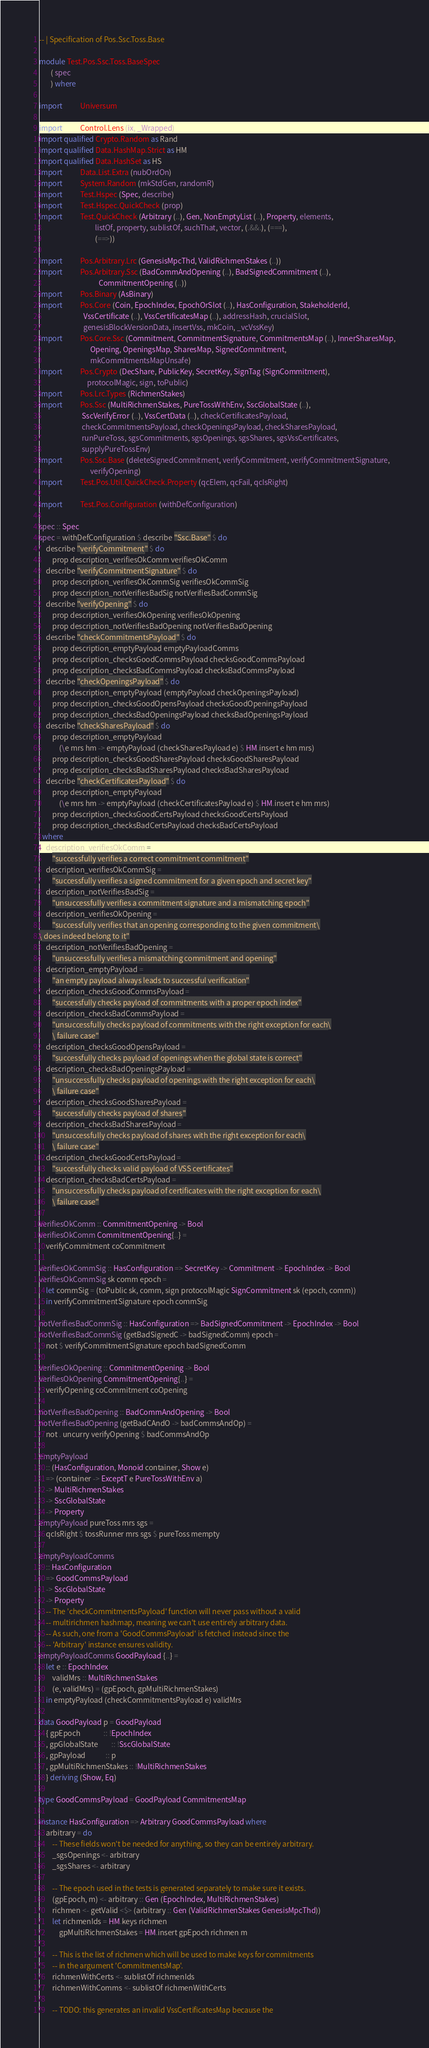<code> <loc_0><loc_0><loc_500><loc_500><_Haskell_>-- | Specification of Pos.Ssc.Toss.Base

module Test.Pos.Ssc.Toss.BaseSpec
       ( spec
       ) where

import           Universum

import           Control.Lens (ix, _Wrapped)
import qualified Crypto.Random as Rand
import qualified Data.HashMap.Strict as HM
import qualified Data.HashSet as HS
import           Data.List.Extra (nubOrdOn)
import           System.Random (mkStdGen, randomR)
import           Test.Hspec (Spec, describe)
import           Test.Hspec.QuickCheck (prop)
import           Test.QuickCheck (Arbitrary (..), Gen, NonEmptyList (..), Property, elements,
                                  listOf, property, sublistOf, suchThat, vector, (.&&.), (===),
                                  (==>))

import           Pos.Arbitrary.Lrc (GenesisMpcThd, ValidRichmenStakes (..))
import           Pos.Arbitrary.Ssc (BadCommAndOpening (..), BadSignedCommitment (..),
                                    CommitmentOpening (..))
import           Pos.Binary (AsBinary)
import           Pos.Core (Coin, EpochIndex, EpochOrSlot (..), HasConfiguration, StakeholderId,
                           VssCertificate (..), VssCertificatesMap (..), addressHash, crucialSlot,
                           genesisBlockVersionData, insertVss, mkCoin, _vcVssKey)
import           Pos.Core.Ssc (Commitment, CommitmentSignature, CommitmentsMap (..), InnerSharesMap,
                               Opening, OpeningsMap, SharesMap, SignedCommitment,
                               mkCommitmentsMapUnsafe)
import           Pos.Crypto (DecShare, PublicKey, SecretKey, SignTag (SignCommitment),
                             protocolMagic, sign, toPublic)
import           Pos.Lrc.Types (RichmenStakes)
import           Pos.Ssc (MultiRichmenStakes, PureTossWithEnv, SscGlobalState (..),
                          SscVerifyError (..), VssCertData (..), checkCertificatesPayload,
                          checkCommitmentsPayload, checkOpeningsPayload, checkSharesPayload,
                          runPureToss, sgsCommitments, sgsOpenings, sgsShares, sgsVssCertificates,
                          supplyPureTossEnv)
import           Pos.Ssc.Base (deleteSignedCommitment, verifyCommitment, verifyCommitmentSignature,
                               verifyOpening)
import           Test.Pos.Util.QuickCheck.Property (qcElem, qcFail, qcIsRight)

import           Test.Pos.Configuration (withDefConfiguration)

spec :: Spec
spec = withDefConfiguration $ describe "Ssc.Base" $ do
    describe "verifyCommitment" $ do
        prop description_verifiesOkComm verifiesOkComm
    describe "verifyCommitmentSignature" $ do
        prop description_verifiesOkCommSig verifiesOkCommSig
        prop description_notVerifiesBadSig notVerifiesBadCommSig
    describe "verifyOpening" $ do
        prop description_verifiesOkOpening verifiesOkOpening
        prop description_notVerifiesBadOpening notVerifiesBadOpening
    describe "checkCommitmentsPayload" $ do
        prop description_emptyPayload emptyPayloadComms
        prop description_checksGoodCommsPayload checksGoodCommsPayload
        prop description_checksBadCommsPayload checksBadCommsPayload
    describe "checkOpeningsPayload" $ do
        prop description_emptyPayload (emptyPayload checkOpeningsPayload)
        prop description_checksGoodOpensPayload checksGoodOpeningsPayload
        prop description_checksBadOpeningsPayload checksBadOpeningsPayload
    describe "checkSharesPayload" $ do
        prop description_emptyPayload
            (\e mrs hm -> emptyPayload (checkSharesPayload e) $ HM.insert e hm mrs)
        prop description_checksGoodSharesPayload checksGoodSharesPayload
        prop description_checksBadSharesPayload checksBadSharesPayload
    describe "checkCertificatesPayload" $ do
        prop description_emptyPayload
            (\e mrs hm -> emptyPayload (checkCertificatesPayload e) $ HM.insert e hm mrs)
        prop description_checksGoodCertsPayload checksGoodCertsPayload
        prop description_checksBadCertsPayload checksBadCertsPayload
  where
    description_verifiesOkComm =
        "successfully verifies a correct commitment commitment"
    description_verifiesOkCommSig =
        "successfully verifies a signed commitment for a given epoch and secret key"
    description_notVerifiesBadSig =
        "unsuccessfully verifies a commitment signature and a mismatching epoch"
    description_verifiesOkOpening =
        "successfully verifies that an opening corresponding to the given commitment\
\ does indeed belong to it"
    description_notVerifiesBadOpening =
        "unsuccessfully verifies a mismatching commitment and opening"
    description_emptyPayload =
        "an empty payload always leads to successful verification"
    description_checksGoodCommsPayload =
        "successfully checks payload of commitments with a proper epoch index"
    description_checksBadCommsPayload =
        "unsuccessfully checks payload of commitments with the right exception for each\
        \ failure case"
    description_checksGoodOpensPayload =
        "successfully checks payload of openings when the global state is correct"
    description_checksBadOpeningsPayload =
        "unsuccessfully checks payload of openings with the right exception for each\
        \ failure case"
    description_checksGoodSharesPayload =
        "successfully checks payload of shares"
    description_checksBadSharesPayload =
        "unsuccessfully checks payload of shares with the right exception for each\
        \ failure case"
    description_checksGoodCertsPayload =
        "successfully checks valid payload of VSS certificates"
    description_checksBadCertsPayload =
        "unsuccessfully checks payload of certificates with the right exception for each\
        \ failure case"

verifiesOkComm :: CommitmentOpening -> Bool
verifiesOkComm CommitmentOpening{..} =
    verifyCommitment coCommitment

verifiesOkCommSig :: HasConfiguration => SecretKey -> Commitment -> EpochIndex -> Bool
verifiesOkCommSig sk comm epoch =
    let commSig = (toPublic sk, comm, sign protocolMagic SignCommitment sk (epoch, comm))
    in verifyCommitmentSignature epoch commSig

notVerifiesBadCommSig :: HasConfiguration => BadSignedCommitment -> EpochIndex -> Bool
notVerifiesBadCommSig (getBadSignedC -> badSignedComm) epoch =
    not $ verifyCommitmentSignature epoch badSignedComm

verifiesOkOpening :: CommitmentOpening -> Bool
verifiesOkOpening CommitmentOpening{..} =
    verifyOpening coCommitment coOpening

notVerifiesBadOpening :: BadCommAndOpening -> Bool
notVerifiesBadOpening (getBadCAndO -> badCommsAndOp) =
    not . uncurry verifyOpening $ badCommsAndOp

emptyPayload
    :: (HasConfiguration, Monoid container, Show e)
    => (container -> ExceptT e PureTossWithEnv a)
    -> MultiRichmenStakes
    -> SscGlobalState
    -> Property
emptyPayload pureToss mrs sgs =
    qcIsRight $ tossRunner mrs sgs $ pureToss mempty

emptyPayloadComms
    :: HasConfiguration
    => GoodCommsPayload
    -> SscGlobalState
    -> Property
    -- The 'checkCommitmentsPayload' function will never pass without a valid
    -- multirichmen hashmap, meaning we can't use entirely arbitrary data.
    -- As such, one from a 'GoodCommsPayload' is fetched instead since the
    -- 'Arbitrary' instance ensures validity.
emptyPayloadComms GoodPayload {..} =
    let e :: EpochIndex
        validMrs :: MultiRichmenStakes
        (e, validMrs) = (gpEpoch, gpMultiRichmenStakes)
    in emptyPayload (checkCommitmentsPayload e) validMrs

data GoodPayload p = GoodPayload
    { gpEpoch              :: !EpochIndex
    , gpGlobalState        :: !SscGlobalState
    , gpPayload            :: p
    , gpMultiRichmenStakes :: !MultiRichmenStakes
    } deriving (Show, Eq)

type GoodCommsPayload = GoodPayload CommitmentsMap

instance HasConfiguration => Arbitrary GoodCommsPayload where
    arbitrary = do
        -- These fields won't be needed for anything, so they can be entirely arbitrary.
        _sgsOpenings <- arbitrary
        _sgsShares <- arbitrary

        -- The epoch used in the tests is generated separately to make sure it exists.
        (gpEpoch, m) <- arbitrary :: Gen (EpochIndex, MultiRichmenStakes)
        richmen <- getValid <$> (arbitrary :: Gen (ValidRichmenStakes GenesisMpcThd))
        let richmenIds = HM.keys richmen
            gpMultiRichmenStakes = HM.insert gpEpoch richmen m

        -- This is the list of richmen which will be used to make keys for commitments
        -- in the argument 'CommitmentsMap'.
        richmenWithCerts <- sublistOf richmenIds
        richmenWithComms <- sublistOf richmenWithCerts

        -- TODO: this generates an invalid VssCertificatesMap because the</code> 